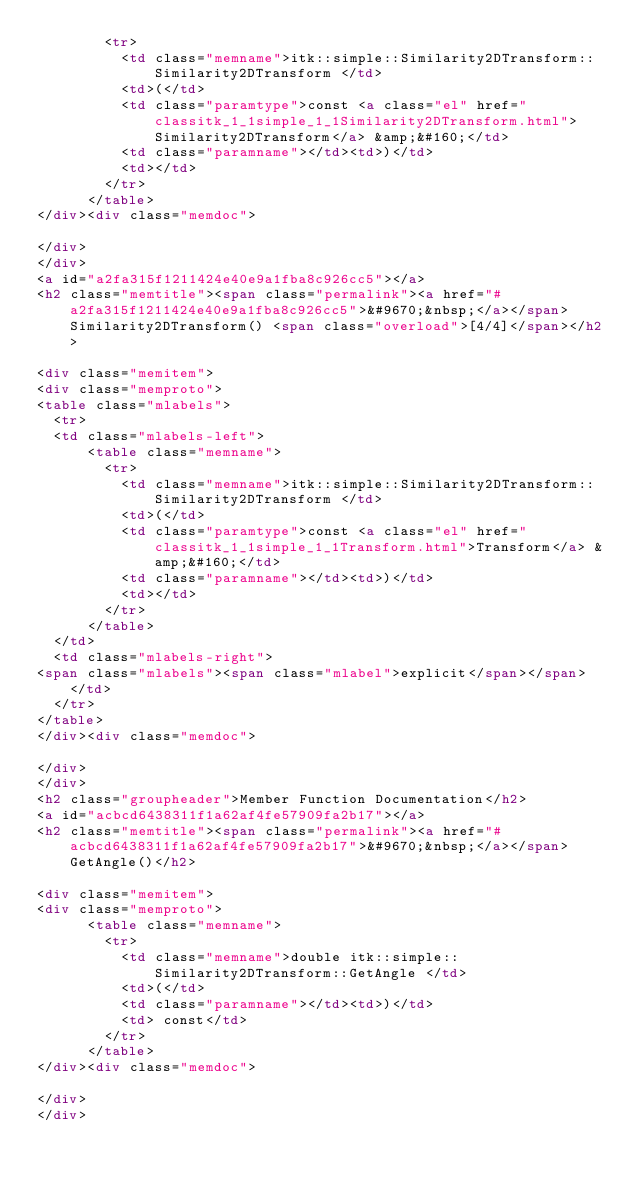<code> <loc_0><loc_0><loc_500><loc_500><_HTML_>        <tr>
          <td class="memname">itk::simple::Similarity2DTransform::Similarity2DTransform </td>
          <td>(</td>
          <td class="paramtype">const <a class="el" href="classitk_1_1simple_1_1Similarity2DTransform.html">Similarity2DTransform</a> &amp;&#160;</td>
          <td class="paramname"></td><td>)</td>
          <td></td>
        </tr>
      </table>
</div><div class="memdoc">

</div>
</div>
<a id="a2fa315f1211424e40e9a1fba8c926cc5"></a>
<h2 class="memtitle"><span class="permalink"><a href="#a2fa315f1211424e40e9a1fba8c926cc5">&#9670;&nbsp;</a></span>Similarity2DTransform() <span class="overload">[4/4]</span></h2>

<div class="memitem">
<div class="memproto">
<table class="mlabels">
  <tr>
  <td class="mlabels-left">
      <table class="memname">
        <tr>
          <td class="memname">itk::simple::Similarity2DTransform::Similarity2DTransform </td>
          <td>(</td>
          <td class="paramtype">const <a class="el" href="classitk_1_1simple_1_1Transform.html">Transform</a> &amp;&#160;</td>
          <td class="paramname"></td><td>)</td>
          <td></td>
        </tr>
      </table>
  </td>
  <td class="mlabels-right">
<span class="mlabels"><span class="mlabel">explicit</span></span>  </td>
  </tr>
</table>
</div><div class="memdoc">

</div>
</div>
<h2 class="groupheader">Member Function Documentation</h2>
<a id="acbcd6438311f1a62af4fe57909fa2b17"></a>
<h2 class="memtitle"><span class="permalink"><a href="#acbcd6438311f1a62af4fe57909fa2b17">&#9670;&nbsp;</a></span>GetAngle()</h2>

<div class="memitem">
<div class="memproto">
      <table class="memname">
        <tr>
          <td class="memname">double itk::simple::Similarity2DTransform::GetAngle </td>
          <td>(</td>
          <td class="paramname"></td><td>)</td>
          <td> const</td>
        </tr>
      </table>
</div><div class="memdoc">

</div>
</div></code> 